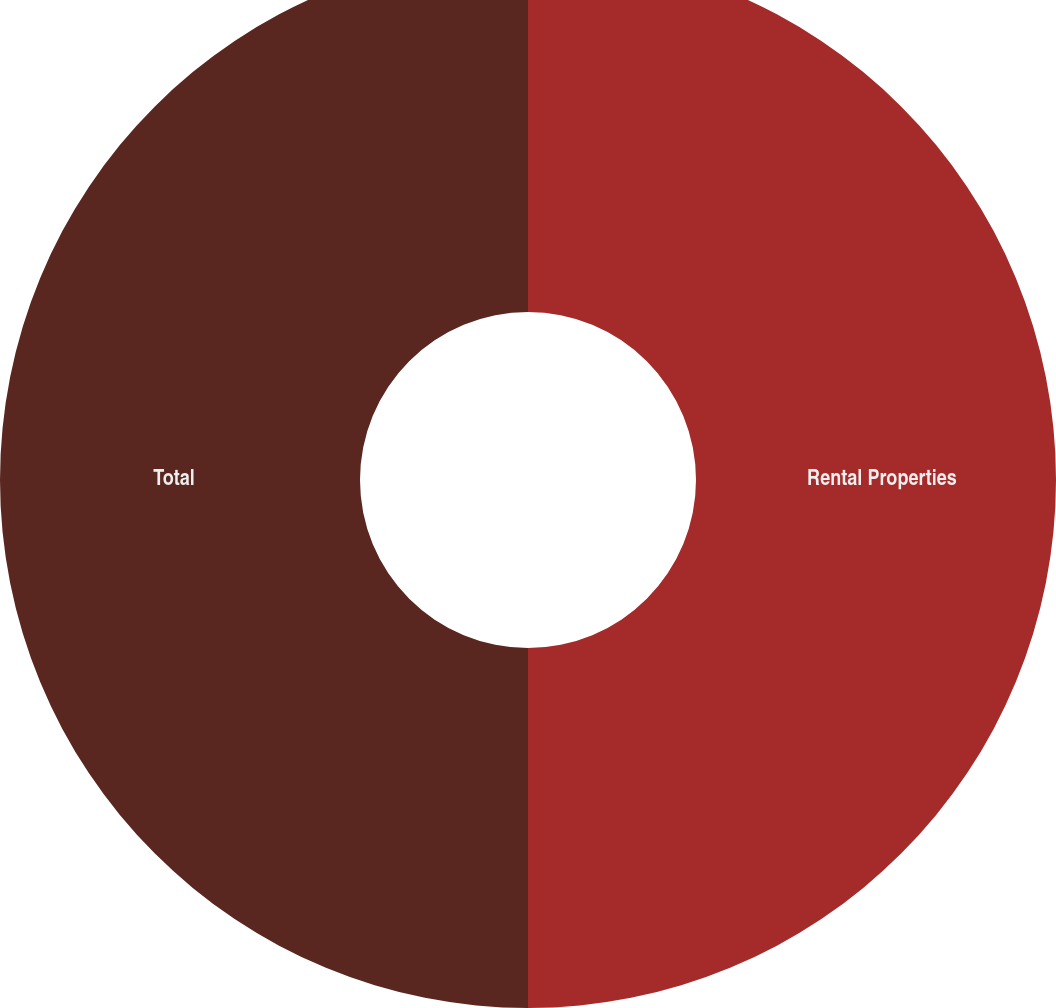Convert chart to OTSL. <chart><loc_0><loc_0><loc_500><loc_500><pie_chart><fcel>Rental Properties<fcel>Total<nl><fcel>50.0%<fcel>50.0%<nl></chart> 